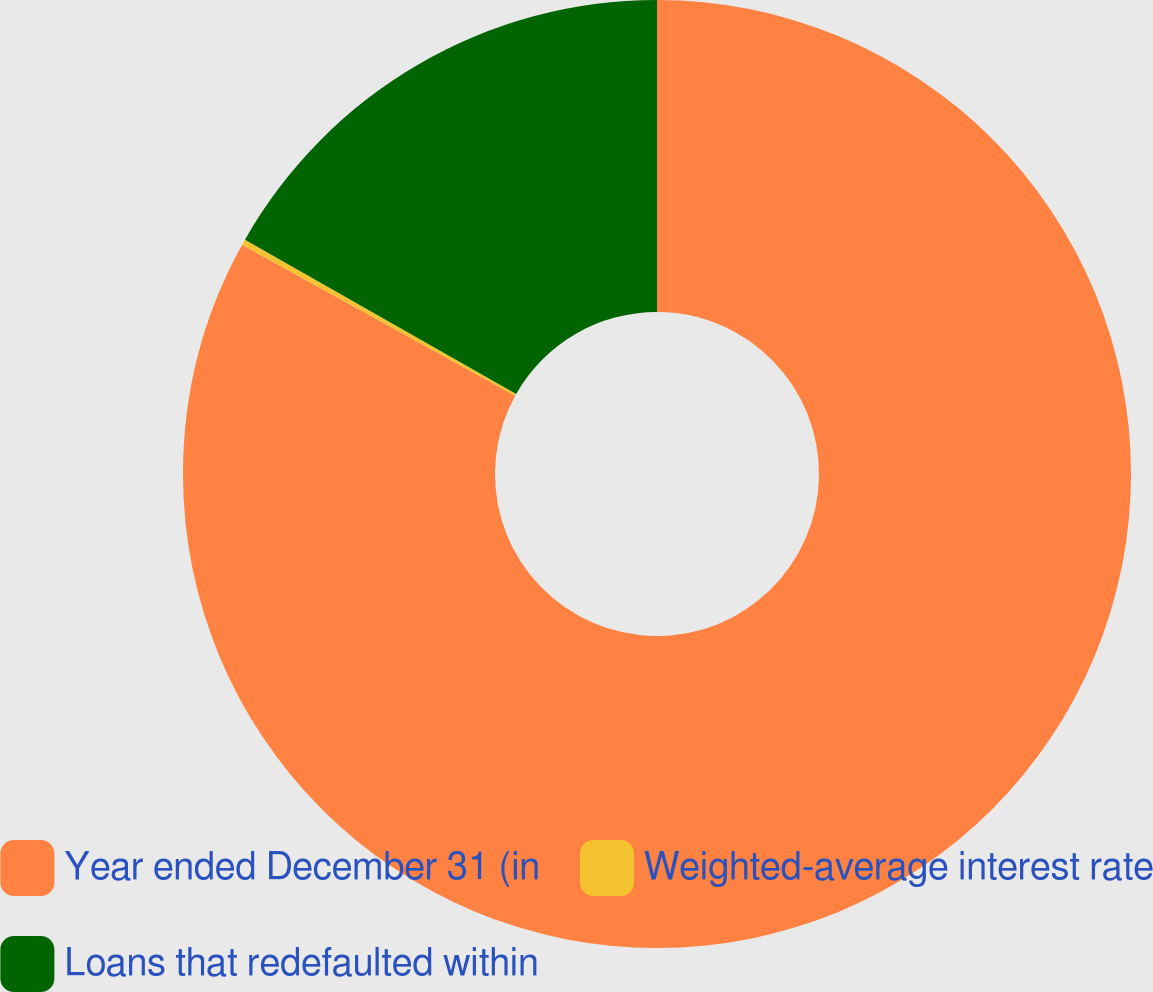<chart> <loc_0><loc_0><loc_500><loc_500><pie_chart><fcel>Year ended December 31 (in<fcel>Weighted-average interest rate<fcel>Loans that redefaulted within<nl><fcel>83.03%<fcel>0.2%<fcel>16.77%<nl></chart> 